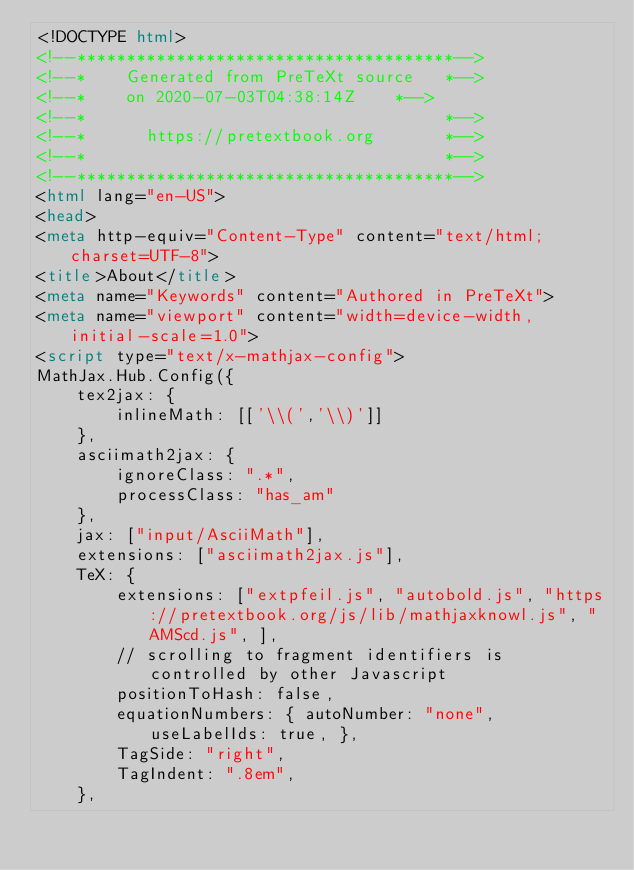<code> <loc_0><loc_0><loc_500><loc_500><_HTML_><!DOCTYPE html>
<!--**************************************-->
<!--*    Generated from PreTeXt source   *-->
<!--*    on 2020-07-03T04:38:14Z    *-->
<!--*                                    *-->
<!--*      https://pretextbook.org       *-->
<!--*                                    *-->
<!--**************************************-->
<html lang="en-US">
<head>
<meta http-equiv="Content-Type" content="text/html; charset=UTF-8">
<title>About</title>
<meta name="Keywords" content="Authored in PreTeXt">
<meta name="viewport" content="width=device-width, initial-scale=1.0">
<script type="text/x-mathjax-config">
MathJax.Hub.Config({
    tex2jax: {
        inlineMath: [['\\(','\\)']]
    },
    asciimath2jax: {
        ignoreClass: ".*",
        processClass: "has_am"
    },
    jax: ["input/AsciiMath"],
    extensions: ["asciimath2jax.js"],
    TeX: {
        extensions: ["extpfeil.js", "autobold.js", "https://pretextbook.org/js/lib/mathjaxknowl.js", "AMScd.js", ],
        // scrolling to fragment identifiers is controlled by other Javascript
        positionToHash: false,
        equationNumbers: { autoNumber: "none", useLabelIds: true, },
        TagSide: "right",
        TagIndent: ".8em",
    },</code> 